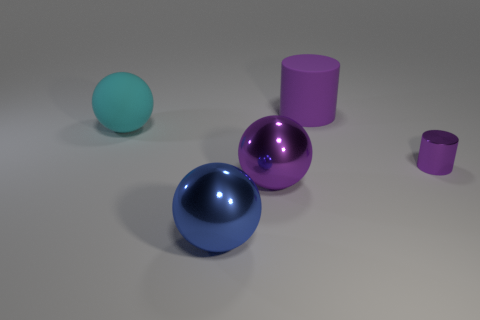There is a cylinder that is in front of the rubber thing that is to the right of the big cyan rubber ball; what is it made of?
Provide a short and direct response. Metal. There is a purple metal thing that is in front of the purple cylinder that is in front of the ball behind the tiny purple metallic object; how big is it?
Provide a succinct answer. Large. What number of other things are the same shape as the cyan rubber thing?
Your response must be concise. 2. Does the metal thing that is to the right of the purple matte cylinder have the same color as the metal ball that is to the left of the purple shiny sphere?
Ensure brevity in your answer.  No. What is the color of the other metal object that is the same size as the blue metal object?
Your response must be concise. Purple. Are there any big metal blocks of the same color as the small metal thing?
Offer a very short reply. No. Does the rubber thing that is in front of the purple rubber cylinder have the same size as the big blue shiny thing?
Provide a succinct answer. Yes. Are there the same number of matte balls that are in front of the large blue shiny sphere and shiny blocks?
Make the answer very short. Yes. How many objects are either big shiny balls that are to the right of the blue ball or small blue cylinders?
Offer a very short reply. 1. There is a large thing that is both behind the large purple metal thing and to the left of the big purple cylinder; what shape is it?
Make the answer very short. Sphere. 